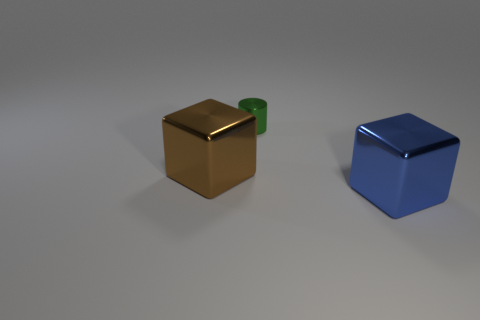What material is the other thing that is the same shape as the brown shiny thing?
Provide a short and direct response. Metal. What number of brown cubes have the same size as the blue metal object?
Offer a very short reply. 1. How many metallic cylinders are there?
Make the answer very short. 1. Do the brown object and the cube that is on the right side of the cylinder have the same material?
Provide a succinct answer. Yes. How many red things are either cylinders or large things?
Make the answer very short. 0. What is the size of the brown object that is made of the same material as the small green thing?
Your response must be concise. Large. How many tiny green metal things are the same shape as the blue metallic object?
Your answer should be compact. 0. Are there more large blue cubes that are left of the large brown metal object than large brown cubes that are right of the big blue shiny thing?
Give a very brief answer. No. Does the tiny thing have the same color as the thing that is right of the cylinder?
Offer a terse response. No. What is the material of the blue cube that is the same size as the brown metal cube?
Provide a succinct answer. Metal. 